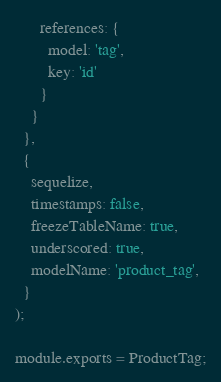<code> <loc_0><loc_0><loc_500><loc_500><_JavaScript_>      references: {
        model: 'tag',
        key: 'id'
      }
    }
  },
  {
    sequelize,
    timestamps: false,
    freezeTableName: true,
    underscored: true,
    modelName: 'product_tag',
  }
);

module.exports = ProductTag;
</code> 